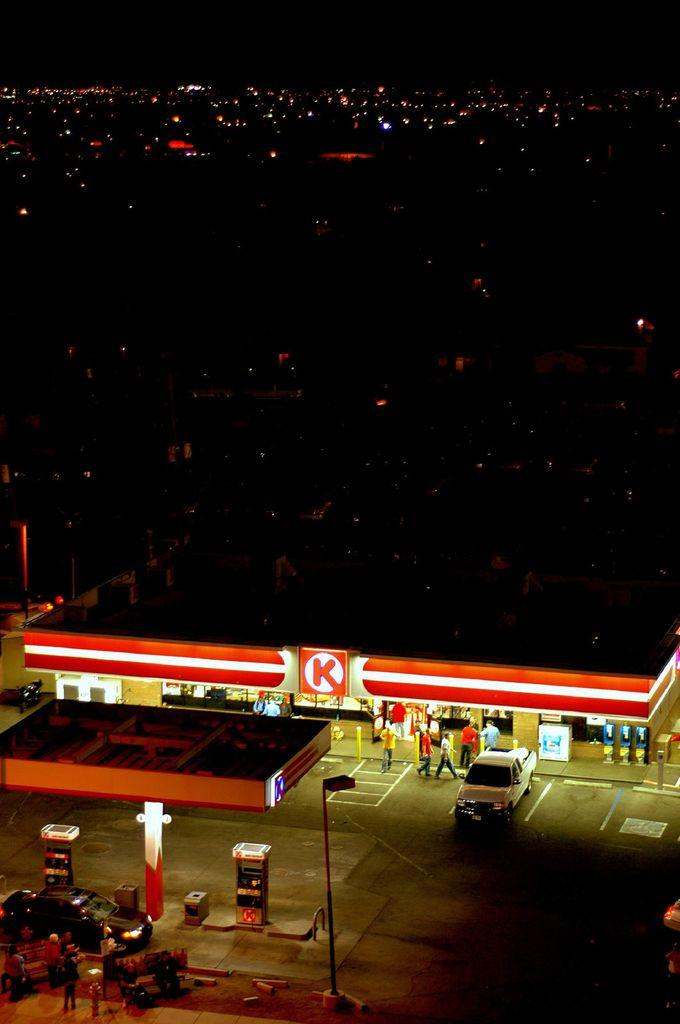<image>
Render a clear and concise summary of the photo. An aerial view of a store with a big K in red on the front. 